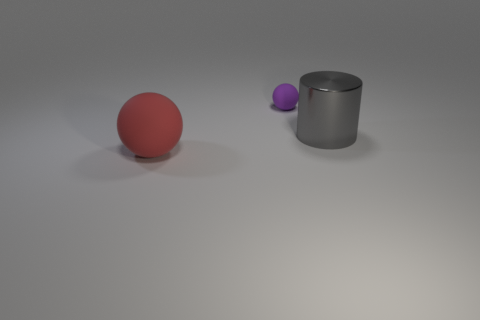Can you comment on the lighting in the scene? The lighting in the scene is soft and diffused, coming from above, as suggested by the subtle shadows below the objects, indicating an indoor setting with probably artificial light sources. Does the lighting affect the color appearance of the objects? Yes, the lighting conditions can influence the perception of color. In this case, the soft light ensures that the colors of the objects are visible but can make them appear slightly less vibrant depending on the intensity and color temperature of the light. 